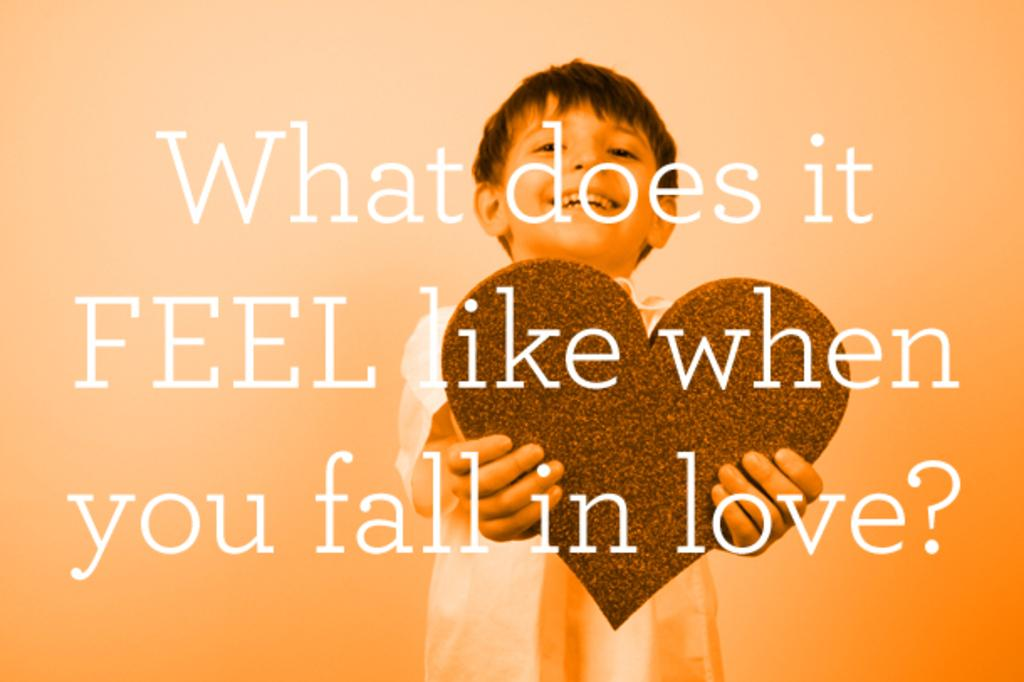What is the main subject of the image? The main subject of the image is a boy. What is the boy doing in the image? The boy is standing and smiling in the image. What is the boy holding in the image? The boy is holding an object in the image. Is there any text on the image? Yes, there is a quotation on the image. What type of guitar is the boy playing in the image? There is no guitar present in the image; the boy is holding an object, but it is not a guitar. Can you see the boy walking on a trail in the image? There is no trail or indication of walking in the image; the boy is standing still. 